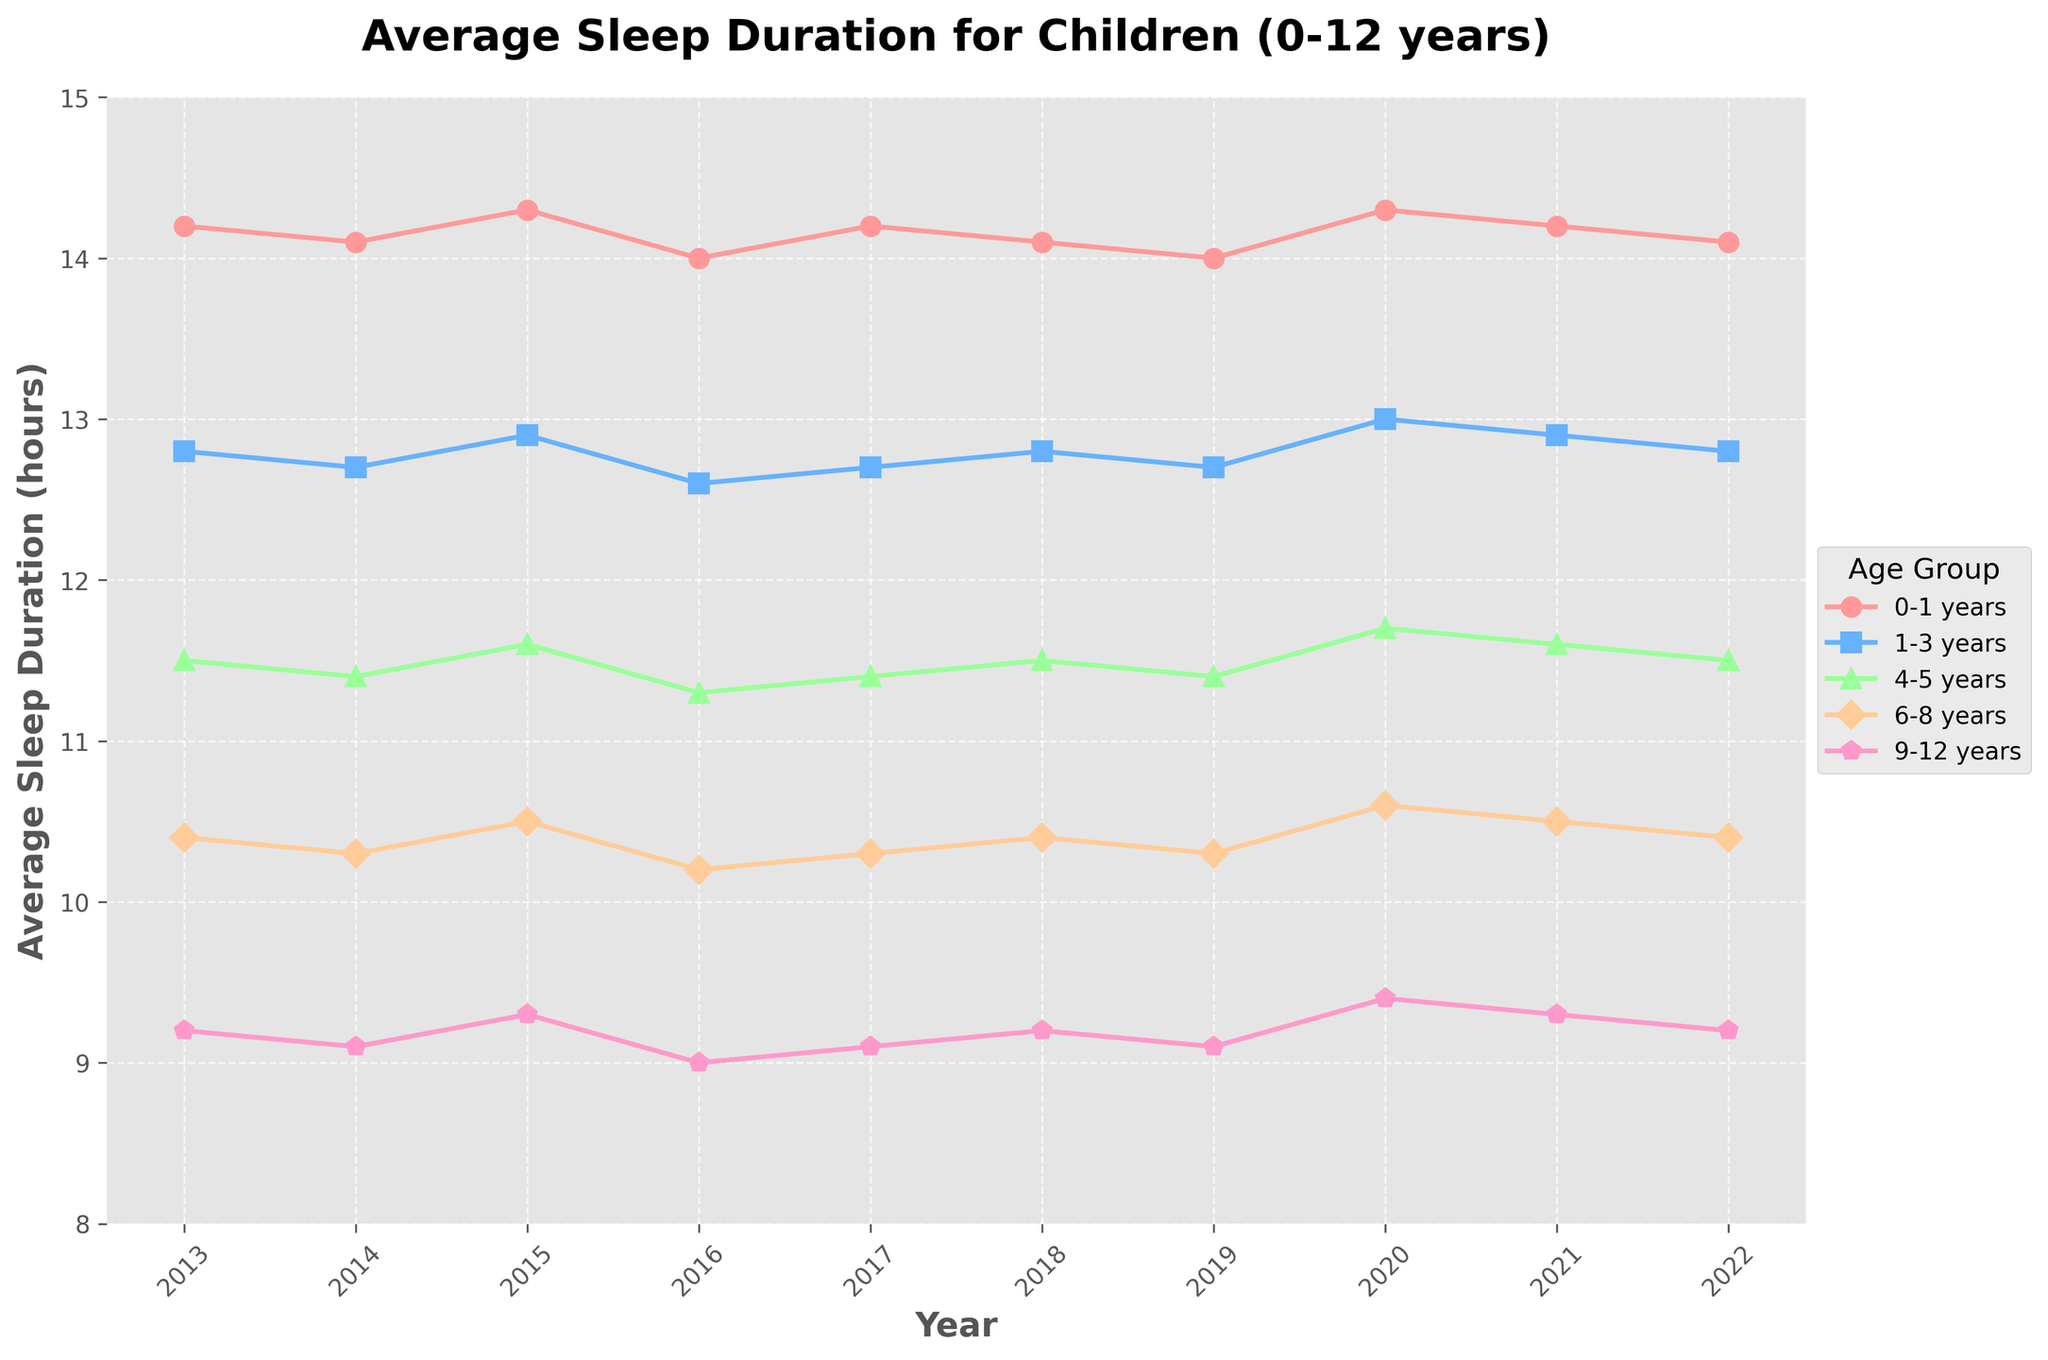What is the overall trend in sleep duration for children aged 0-1 years from 2013 to 2022? The trend appears to be relatively stable, with slight fluctuations around 14-14.3 hours.
Answer: Stable trend In which year did children aged 6-8 years have the highest average sleep duration? The line for the 6-8 years age group peaks in 2020 with an average sleep duration of 10.6 hours.
Answer: 2020 How does the average sleep duration of 1-3 years compare to 9-12 years in 2018? In 2018, the average sleep duration for 1-3 years was 12.8 hours, while for 9-12 years, it was 9.2 hours.
Answer: Higher for 1-3 years Which age group has the most fluctuating sleep duration over the decade, and how can you tell? The 6-8 years age group shows the most fluctuation, as it has noticeable peaks and troughs compared to other age groups.
Answer: 6-8 years What is the difference in average sleep duration between children aged 0-1 years and 4-5 years in 2015? In 2015, the average sleep duration for 0-1 years was 14.3 hours, and for 4-5 years it was 11.6 hours, resulting in a difference of 14.3 - 11.6 = 2.7 hours.
Answer: 2.7 hours Which age group shows a consistent increase in sleep duration from 2016 to 2020? The line for children aged 1-3 years shows a consistent increase from 12.6 hours in 2016 to 13.0 hours in 2020.
Answer: 1-3 years Based on the figure, what age group had the lowest average sleep duration in 2022 and what was it? In 2022, the 9-12 years age group had the lowest average sleep duration at 9.2 hours.
Answer: 9-12 years Compare the sleep duration trends of the 4-5 years and 6-8 years age groups from 2013 to 2022. Both age groups have a relatively stable trend with slight variations. However, the sleep duration for 4-5 years is consistently higher than that for 6-8 years.
Answer: 4-5 years consistently higher What visual clues can you use to differentiate the age groups in the plot? Different age groups are distinguished by different colors and markers (e.g., circles, squares) on their respective lines.
Answer: Colors and markers Calculate the average sleep duration for children aged 9-12 years over the entire decade. Sum of sleep durations from 2013 to 2022 is 9.2 + 9.1 + 9.3 + 9.0 + 9.1 + 9.2 + 9.1 + 9.4 + 9.3 + 9.2 = 92.9 hours. Divide by 10 years to get 92.9 / 10 = 9.29 hours.
Answer: 9.29 hours 